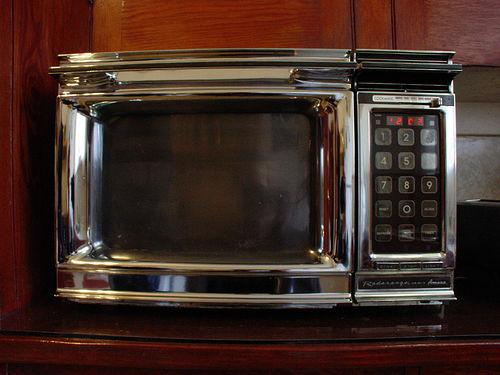Provide an informal summary of the main item in the image and its various parts. A cool silver microwave placed below some cabinets has got red digital display, number pad, a bunch of buttons, and a see-through door. Provide a short description of the major object in the image. A silver microwave is situated below wooden cabinets and has a digital timer with red numbers, a number keypad, and several buttons on its front. Mention the primary features of the microwave in a concise manner. Silver microwave with digital timer, number keypad, see-through door, and various buttons mounted below wooden cabinets. Create a condensed description of the primary object and its notable visual components. Silver microwave under cabinets featuring digital timer, number pad, glass door, and multiple buttons. State the core subject of the image and list its distinctive components. A silver and black microwave under cabinets, featuring a red digital timer, number keypad, see-through door, and a variety of buttons. Describe the key object and its components in a simple sentence. A silver microwave below cabinets has a digital timer, number keypad, see-through door, and several buttons. In a casual tone, mention the main item in the image and its key attributes. There's a silver microwave sitting right under the cabinets, and it's got a red digital timer, numeric pad, clear door, and loads of buttons on it. In a single sentence, identify the main subject in the picture and its most important features. The image displays a silver microwave positioned under cabinets, equipped with a digital timer, number keypad, transparent door, and numerous buttons. Briefly explain the primary object in the image and what it looks like. The main object is a silver microwave with a digital timer showing red numbers, a number pad, transparent door, and multiple buttons, resting under wooden cabinets. Write a brief statement about the main appliance in the image and its location. The image showcases a silver and black microwave positioned on a shelf beneath brown cabinets. 